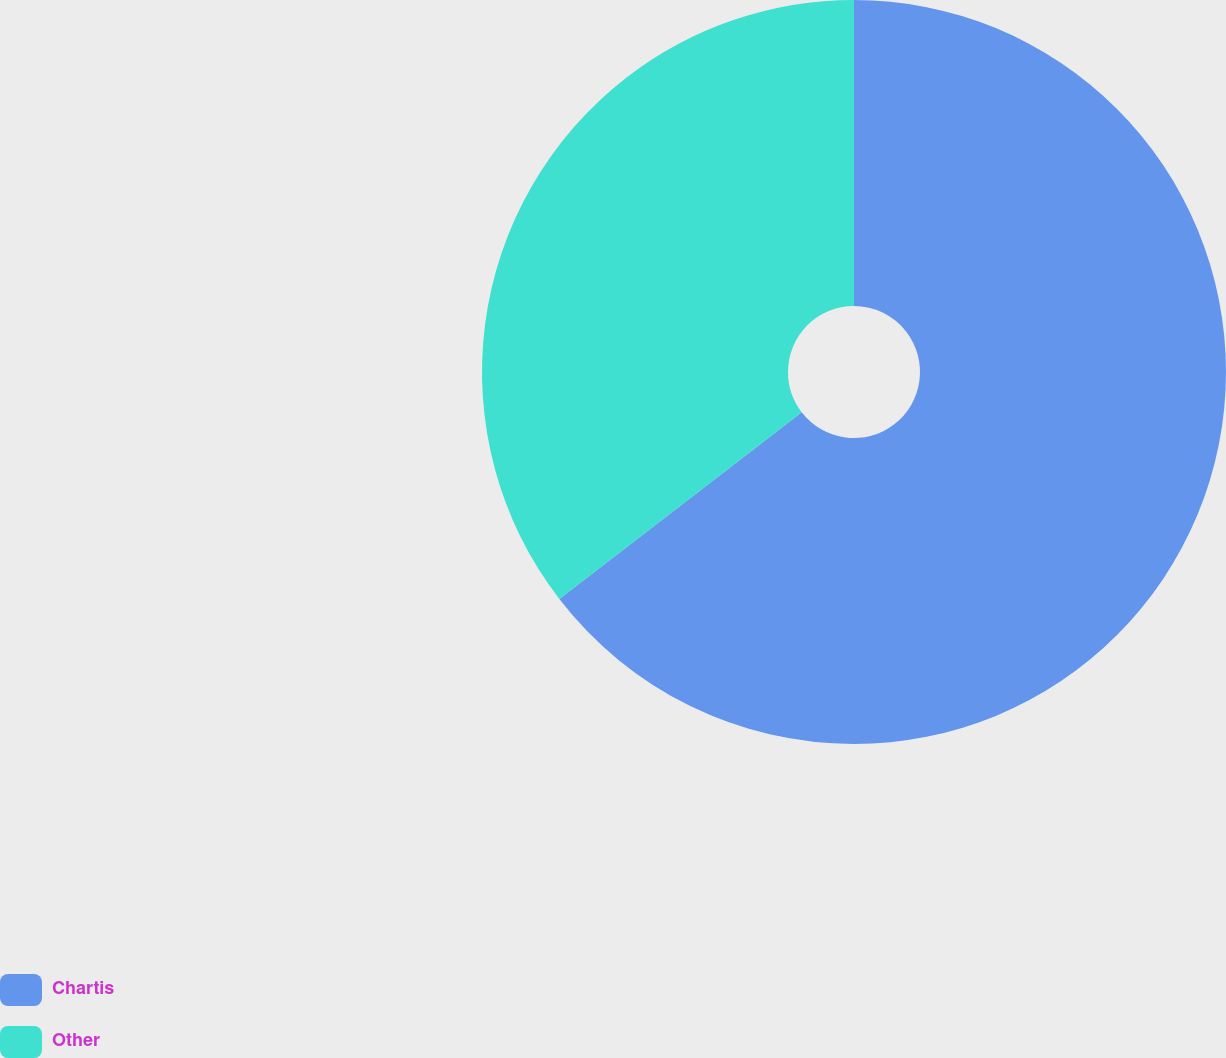Convert chart to OTSL. <chart><loc_0><loc_0><loc_500><loc_500><pie_chart><fcel>Chartis<fcel>Other<nl><fcel>64.55%<fcel>35.45%<nl></chart> 